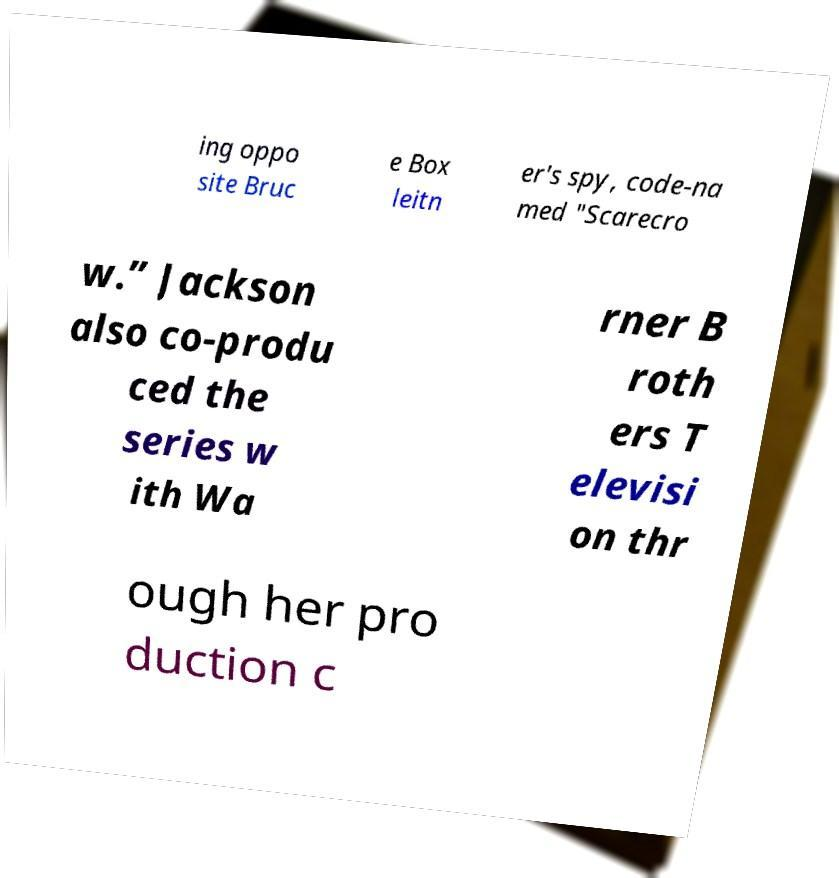For documentation purposes, I need the text within this image transcribed. Could you provide that? ing oppo site Bruc e Box leitn er's spy, code-na med "Scarecro w.” Jackson also co-produ ced the series w ith Wa rner B roth ers T elevisi on thr ough her pro duction c 